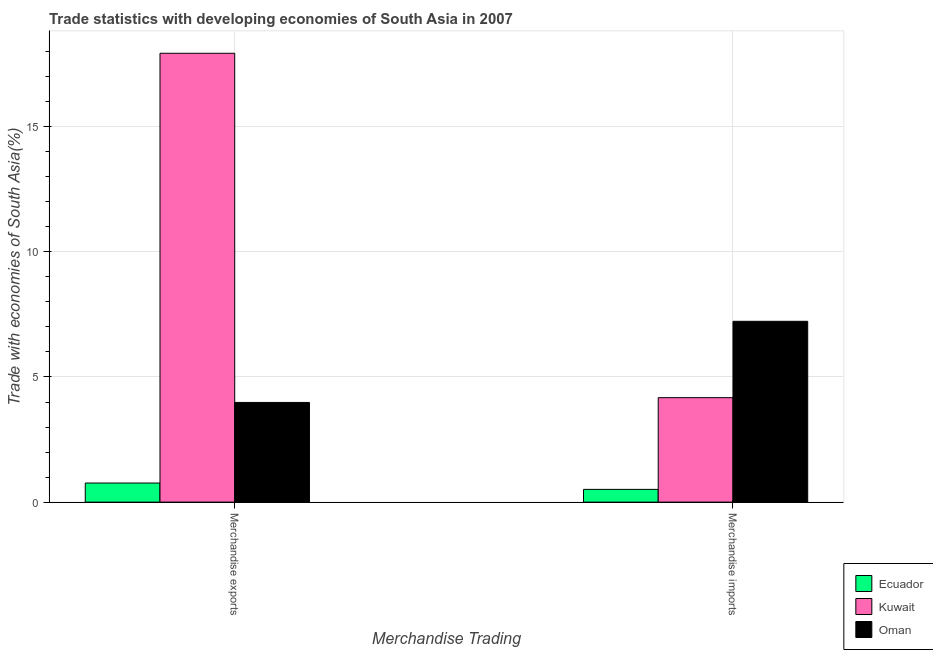How many different coloured bars are there?
Your response must be concise. 3. Are the number of bars per tick equal to the number of legend labels?
Your answer should be compact. Yes. Are the number of bars on each tick of the X-axis equal?
Your answer should be compact. Yes. How many bars are there on the 1st tick from the right?
Give a very brief answer. 3. What is the label of the 2nd group of bars from the left?
Offer a terse response. Merchandise imports. What is the merchandise exports in Ecuador?
Offer a very short reply. 0.76. Across all countries, what is the maximum merchandise exports?
Keep it short and to the point. 17.93. Across all countries, what is the minimum merchandise exports?
Provide a succinct answer. 0.76. In which country was the merchandise exports maximum?
Your response must be concise. Kuwait. In which country was the merchandise exports minimum?
Provide a short and direct response. Ecuador. What is the total merchandise exports in the graph?
Make the answer very short. 22.68. What is the difference between the merchandise exports in Ecuador and that in Oman?
Your answer should be compact. -3.22. What is the difference between the merchandise imports in Oman and the merchandise exports in Kuwait?
Offer a terse response. -10.71. What is the average merchandise imports per country?
Your response must be concise. 3.97. What is the difference between the merchandise exports and merchandise imports in Oman?
Provide a short and direct response. -3.24. What is the ratio of the merchandise exports in Ecuador to that in Oman?
Provide a succinct answer. 0.19. What does the 1st bar from the left in Merchandise exports represents?
Keep it short and to the point. Ecuador. What does the 3rd bar from the right in Merchandise imports represents?
Offer a terse response. Ecuador. Are all the bars in the graph horizontal?
Your answer should be compact. No. What is the difference between two consecutive major ticks on the Y-axis?
Make the answer very short. 5. Are the values on the major ticks of Y-axis written in scientific E-notation?
Ensure brevity in your answer.  No. How many legend labels are there?
Your answer should be very brief. 3. What is the title of the graph?
Make the answer very short. Trade statistics with developing economies of South Asia in 2007. Does "Europe(all income levels)" appear as one of the legend labels in the graph?
Provide a succinct answer. No. What is the label or title of the X-axis?
Your answer should be very brief. Merchandise Trading. What is the label or title of the Y-axis?
Your answer should be compact. Trade with economies of South Asia(%). What is the Trade with economies of South Asia(%) of Ecuador in Merchandise exports?
Offer a terse response. 0.76. What is the Trade with economies of South Asia(%) of Kuwait in Merchandise exports?
Ensure brevity in your answer.  17.93. What is the Trade with economies of South Asia(%) of Oman in Merchandise exports?
Offer a terse response. 3.98. What is the Trade with economies of South Asia(%) of Ecuador in Merchandise imports?
Make the answer very short. 0.51. What is the Trade with economies of South Asia(%) of Kuwait in Merchandise imports?
Your answer should be compact. 4.17. What is the Trade with economies of South Asia(%) of Oman in Merchandise imports?
Offer a very short reply. 7.22. Across all Merchandise Trading, what is the maximum Trade with economies of South Asia(%) in Ecuador?
Ensure brevity in your answer.  0.76. Across all Merchandise Trading, what is the maximum Trade with economies of South Asia(%) of Kuwait?
Give a very brief answer. 17.93. Across all Merchandise Trading, what is the maximum Trade with economies of South Asia(%) in Oman?
Your response must be concise. 7.22. Across all Merchandise Trading, what is the minimum Trade with economies of South Asia(%) in Ecuador?
Offer a very short reply. 0.51. Across all Merchandise Trading, what is the minimum Trade with economies of South Asia(%) of Kuwait?
Offer a very short reply. 4.17. Across all Merchandise Trading, what is the minimum Trade with economies of South Asia(%) in Oman?
Offer a very short reply. 3.98. What is the total Trade with economies of South Asia(%) of Ecuador in the graph?
Keep it short and to the point. 1.27. What is the total Trade with economies of South Asia(%) of Kuwait in the graph?
Provide a succinct answer. 22.11. What is the total Trade with economies of South Asia(%) of Oman in the graph?
Offer a very short reply. 11.21. What is the difference between the Trade with economies of South Asia(%) of Ecuador in Merchandise exports and that in Merchandise imports?
Offer a very short reply. 0.25. What is the difference between the Trade with economies of South Asia(%) in Kuwait in Merchandise exports and that in Merchandise imports?
Give a very brief answer. 13.76. What is the difference between the Trade with economies of South Asia(%) of Oman in Merchandise exports and that in Merchandise imports?
Keep it short and to the point. -3.24. What is the difference between the Trade with economies of South Asia(%) of Ecuador in Merchandise exports and the Trade with economies of South Asia(%) of Kuwait in Merchandise imports?
Make the answer very short. -3.41. What is the difference between the Trade with economies of South Asia(%) of Ecuador in Merchandise exports and the Trade with economies of South Asia(%) of Oman in Merchandise imports?
Ensure brevity in your answer.  -6.46. What is the difference between the Trade with economies of South Asia(%) of Kuwait in Merchandise exports and the Trade with economies of South Asia(%) of Oman in Merchandise imports?
Your answer should be compact. 10.71. What is the average Trade with economies of South Asia(%) of Ecuador per Merchandise Trading?
Your answer should be very brief. 0.64. What is the average Trade with economies of South Asia(%) of Kuwait per Merchandise Trading?
Offer a very short reply. 11.05. What is the average Trade with economies of South Asia(%) of Oman per Merchandise Trading?
Provide a succinct answer. 5.6. What is the difference between the Trade with economies of South Asia(%) of Ecuador and Trade with economies of South Asia(%) of Kuwait in Merchandise exports?
Your response must be concise. -17.17. What is the difference between the Trade with economies of South Asia(%) of Ecuador and Trade with economies of South Asia(%) of Oman in Merchandise exports?
Provide a succinct answer. -3.22. What is the difference between the Trade with economies of South Asia(%) in Kuwait and Trade with economies of South Asia(%) in Oman in Merchandise exports?
Offer a terse response. 13.95. What is the difference between the Trade with economies of South Asia(%) of Ecuador and Trade with economies of South Asia(%) of Kuwait in Merchandise imports?
Provide a succinct answer. -3.66. What is the difference between the Trade with economies of South Asia(%) in Ecuador and Trade with economies of South Asia(%) in Oman in Merchandise imports?
Provide a short and direct response. -6.71. What is the difference between the Trade with economies of South Asia(%) in Kuwait and Trade with economies of South Asia(%) in Oman in Merchandise imports?
Offer a terse response. -3.05. What is the ratio of the Trade with economies of South Asia(%) of Ecuador in Merchandise exports to that in Merchandise imports?
Your answer should be compact. 1.5. What is the ratio of the Trade with economies of South Asia(%) in Kuwait in Merchandise exports to that in Merchandise imports?
Offer a terse response. 4.3. What is the ratio of the Trade with economies of South Asia(%) in Oman in Merchandise exports to that in Merchandise imports?
Provide a succinct answer. 0.55. What is the difference between the highest and the second highest Trade with economies of South Asia(%) of Ecuador?
Give a very brief answer. 0.25. What is the difference between the highest and the second highest Trade with economies of South Asia(%) in Kuwait?
Offer a very short reply. 13.76. What is the difference between the highest and the second highest Trade with economies of South Asia(%) in Oman?
Ensure brevity in your answer.  3.24. What is the difference between the highest and the lowest Trade with economies of South Asia(%) in Ecuador?
Your answer should be very brief. 0.25. What is the difference between the highest and the lowest Trade with economies of South Asia(%) of Kuwait?
Provide a succinct answer. 13.76. What is the difference between the highest and the lowest Trade with economies of South Asia(%) of Oman?
Your response must be concise. 3.24. 